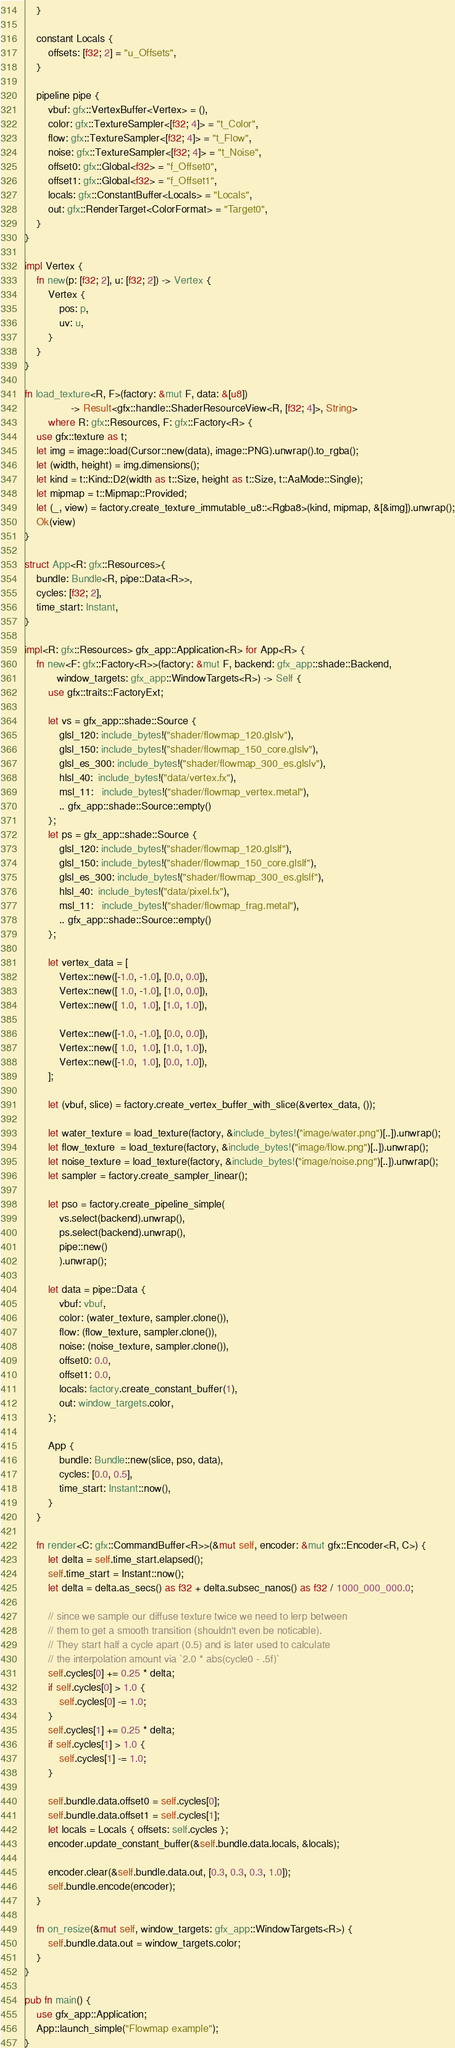Convert code to text. <code><loc_0><loc_0><loc_500><loc_500><_Rust_>    }

    constant Locals {
        offsets: [f32; 2] = "u_Offsets",
    }

    pipeline pipe {
        vbuf: gfx::VertexBuffer<Vertex> = (),
        color: gfx::TextureSampler<[f32; 4]> = "t_Color",
        flow: gfx::TextureSampler<[f32; 4]> = "t_Flow",
        noise: gfx::TextureSampler<[f32; 4]> = "t_Noise",
        offset0: gfx::Global<f32> = "f_Offset0",
        offset1: gfx::Global<f32> = "f_Offset1",
        locals: gfx::ConstantBuffer<Locals> = "Locals",
        out: gfx::RenderTarget<ColorFormat> = "Target0",
    }
}

impl Vertex {
    fn new(p: [f32; 2], u: [f32; 2]) -> Vertex {
        Vertex {
            pos: p,
            uv: u,
        }
    }
}

fn load_texture<R, F>(factory: &mut F, data: &[u8])
                -> Result<gfx::handle::ShaderResourceView<R, [f32; 4]>, String>
        where R: gfx::Resources, F: gfx::Factory<R> {
    use gfx::texture as t;
    let img = image::load(Cursor::new(data), image::PNG).unwrap().to_rgba();
    let (width, height) = img.dimensions();
    let kind = t::Kind::D2(width as t::Size, height as t::Size, t::AaMode::Single);
    let mipmap = t::Mipmap::Provided;
    let (_, view) = factory.create_texture_immutable_u8::<Rgba8>(kind, mipmap, &[&img]).unwrap();
    Ok(view)
}

struct App<R: gfx::Resources>{
    bundle: Bundle<R, pipe::Data<R>>,
    cycles: [f32; 2],
    time_start: Instant,
}

impl<R: gfx::Resources> gfx_app::Application<R> for App<R> {
    fn new<F: gfx::Factory<R>>(factory: &mut F, backend: gfx_app::shade::Backend,
           window_targets: gfx_app::WindowTargets<R>) -> Self {
        use gfx::traits::FactoryExt;

        let vs = gfx_app::shade::Source {
            glsl_120: include_bytes!("shader/flowmap_120.glslv"),
            glsl_150: include_bytes!("shader/flowmap_150_core.glslv"),
            glsl_es_300: include_bytes!("shader/flowmap_300_es.glslv"),
            hlsl_40:  include_bytes!("data/vertex.fx"),
            msl_11:   include_bytes!("shader/flowmap_vertex.metal"),
            .. gfx_app::shade::Source::empty()
        };
        let ps = gfx_app::shade::Source {
            glsl_120: include_bytes!("shader/flowmap_120.glslf"),
            glsl_150: include_bytes!("shader/flowmap_150_core.glslf"),
            glsl_es_300: include_bytes!("shader/flowmap_300_es.glslf"),
            hlsl_40:  include_bytes!("data/pixel.fx"),
            msl_11:   include_bytes!("shader/flowmap_frag.metal"),
            .. gfx_app::shade::Source::empty()
        };

        let vertex_data = [
            Vertex::new([-1.0, -1.0], [0.0, 0.0]),
            Vertex::new([ 1.0, -1.0], [1.0, 0.0]),
            Vertex::new([ 1.0,  1.0], [1.0, 1.0]),

            Vertex::new([-1.0, -1.0], [0.0, 0.0]),
            Vertex::new([ 1.0,  1.0], [1.0, 1.0]),
            Vertex::new([-1.0,  1.0], [0.0, 1.0]),
        ];

        let (vbuf, slice) = factory.create_vertex_buffer_with_slice(&vertex_data, ());

        let water_texture = load_texture(factory, &include_bytes!("image/water.png")[..]).unwrap();
        let flow_texture  = load_texture(factory, &include_bytes!("image/flow.png")[..]).unwrap();
        let noise_texture = load_texture(factory, &include_bytes!("image/noise.png")[..]).unwrap();
        let sampler = factory.create_sampler_linear();

        let pso = factory.create_pipeline_simple(
            vs.select(backend).unwrap(),
            ps.select(backend).unwrap(),
            pipe::new()
            ).unwrap();

        let data = pipe::Data {
            vbuf: vbuf,
            color: (water_texture, sampler.clone()),
            flow: (flow_texture, sampler.clone()),
            noise: (noise_texture, sampler.clone()),
            offset0: 0.0,
            offset1: 0.0,
            locals: factory.create_constant_buffer(1),
            out: window_targets.color,
        };

        App {
            bundle: Bundle::new(slice, pso, data),
            cycles: [0.0, 0.5],
            time_start: Instant::now(),
        }
    }

    fn render<C: gfx::CommandBuffer<R>>(&mut self, encoder: &mut gfx::Encoder<R, C>) {
        let delta = self.time_start.elapsed();
        self.time_start = Instant::now();
        let delta = delta.as_secs() as f32 + delta.subsec_nanos() as f32 / 1000_000_000.0;

        // since we sample our diffuse texture twice we need to lerp between
        // them to get a smooth transition (shouldn't even be noticable).
        // They start half a cycle apart (0.5) and is later used to calculate
        // the interpolation amount via `2.0 * abs(cycle0 - .5f)`
        self.cycles[0] += 0.25 * delta;
        if self.cycles[0] > 1.0 {
            self.cycles[0] -= 1.0;
        }
        self.cycles[1] += 0.25 * delta;
        if self.cycles[1] > 1.0 {
            self.cycles[1] -= 1.0;
        }

        self.bundle.data.offset0 = self.cycles[0];
        self.bundle.data.offset1 = self.cycles[1];
        let locals = Locals { offsets: self.cycles };
        encoder.update_constant_buffer(&self.bundle.data.locals, &locals);

        encoder.clear(&self.bundle.data.out, [0.3, 0.3, 0.3, 1.0]);
        self.bundle.encode(encoder);
    }

    fn on_resize(&mut self, window_targets: gfx_app::WindowTargets<R>) {
        self.bundle.data.out = window_targets.color;
    }
}

pub fn main() {
    use gfx_app::Application;
    App::launch_simple("Flowmap example");
}
</code> 